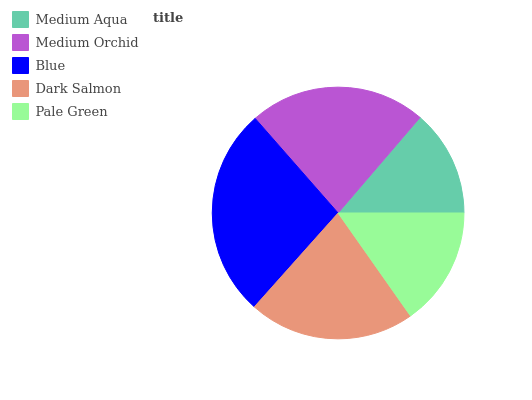Is Medium Aqua the minimum?
Answer yes or no. Yes. Is Blue the maximum?
Answer yes or no. Yes. Is Medium Orchid the minimum?
Answer yes or no. No. Is Medium Orchid the maximum?
Answer yes or no. No. Is Medium Orchid greater than Medium Aqua?
Answer yes or no. Yes. Is Medium Aqua less than Medium Orchid?
Answer yes or no. Yes. Is Medium Aqua greater than Medium Orchid?
Answer yes or no. No. Is Medium Orchid less than Medium Aqua?
Answer yes or no. No. Is Dark Salmon the high median?
Answer yes or no. Yes. Is Dark Salmon the low median?
Answer yes or no. Yes. Is Medium Aqua the high median?
Answer yes or no. No. Is Medium Aqua the low median?
Answer yes or no. No. 